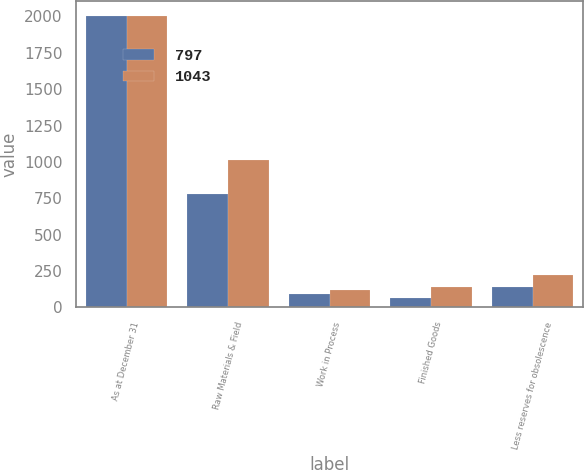Convert chart. <chart><loc_0><loc_0><loc_500><loc_500><stacked_bar_chart><ecel><fcel>As at December 31<fcel>Raw Materials & Field<fcel>Work in Process<fcel>Finished Goods<fcel>Less reserves for obsolescence<nl><fcel>797<fcel>2003<fcel>778<fcel>96<fcel>62<fcel>139<nl><fcel>1043<fcel>2002<fcel>1010<fcel>118<fcel>138<fcel>223<nl></chart> 